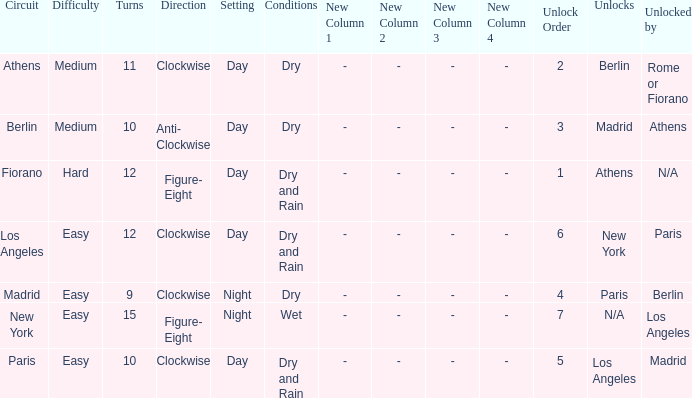How many instances is the unlocked n/a? 1.0. 